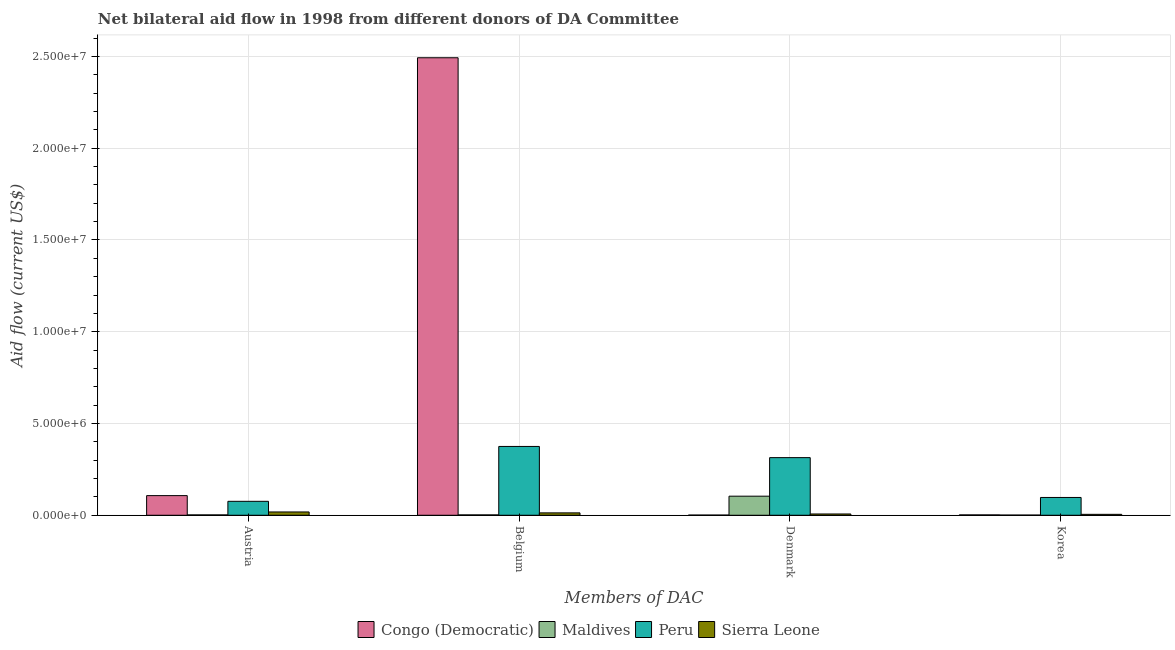Are the number of bars per tick equal to the number of legend labels?
Provide a short and direct response. Yes. Are the number of bars on each tick of the X-axis equal?
Offer a very short reply. Yes. How many bars are there on the 4th tick from the left?
Keep it short and to the point. 4. How many bars are there on the 3rd tick from the right?
Provide a succinct answer. 4. What is the amount of aid given by korea in Sierra Leone?
Your answer should be compact. 5.00e+04. Across all countries, what is the maximum amount of aid given by austria?
Offer a terse response. 1.07e+06. Across all countries, what is the minimum amount of aid given by austria?
Keep it short and to the point. 2.00e+04. In which country was the amount of aid given by austria minimum?
Provide a succinct answer. Maldives. What is the total amount of aid given by belgium in the graph?
Keep it short and to the point. 2.88e+07. What is the difference between the amount of aid given by korea in Sierra Leone and that in Congo (Democratic)?
Your answer should be very brief. 3.00e+04. What is the difference between the amount of aid given by belgium in Congo (Democratic) and the amount of aid given by korea in Maldives?
Keep it short and to the point. 2.49e+07. What is the average amount of aid given by korea per country?
Provide a short and direct response. 2.62e+05. What is the difference between the amount of aid given by austria and amount of aid given by denmark in Sierra Leone?
Offer a terse response. 1.10e+05. In how many countries, is the amount of aid given by belgium greater than 18000000 US$?
Keep it short and to the point. 1. Is the difference between the amount of aid given by korea in Congo (Democratic) and Sierra Leone greater than the difference between the amount of aid given by belgium in Congo (Democratic) and Sierra Leone?
Make the answer very short. No. What is the difference between the highest and the second highest amount of aid given by austria?
Your answer should be compact. 3.10e+05. What is the difference between the highest and the lowest amount of aid given by korea?
Offer a very short reply. 9.60e+05. What does the 2nd bar from the left in Austria represents?
Offer a very short reply. Maldives. What does the 1st bar from the right in Belgium represents?
Keep it short and to the point. Sierra Leone. What is the difference between two consecutive major ticks on the Y-axis?
Provide a succinct answer. 5.00e+06. Are the values on the major ticks of Y-axis written in scientific E-notation?
Ensure brevity in your answer.  Yes. Where does the legend appear in the graph?
Provide a succinct answer. Bottom center. How are the legend labels stacked?
Your answer should be compact. Horizontal. What is the title of the graph?
Your answer should be compact. Net bilateral aid flow in 1998 from different donors of DA Committee. What is the label or title of the X-axis?
Provide a short and direct response. Members of DAC. What is the label or title of the Y-axis?
Your answer should be compact. Aid flow (current US$). What is the Aid flow (current US$) in Congo (Democratic) in Austria?
Provide a succinct answer. 1.07e+06. What is the Aid flow (current US$) in Maldives in Austria?
Give a very brief answer. 2.00e+04. What is the Aid flow (current US$) in Peru in Austria?
Your response must be concise. 7.60e+05. What is the Aid flow (current US$) in Sierra Leone in Austria?
Make the answer very short. 1.80e+05. What is the Aid flow (current US$) of Congo (Democratic) in Belgium?
Offer a terse response. 2.49e+07. What is the Aid flow (current US$) in Maldives in Belgium?
Your response must be concise. 2.00e+04. What is the Aid flow (current US$) in Peru in Belgium?
Provide a succinct answer. 3.75e+06. What is the Aid flow (current US$) of Congo (Democratic) in Denmark?
Your answer should be very brief. 10000. What is the Aid flow (current US$) in Maldives in Denmark?
Your answer should be compact. 1.04e+06. What is the Aid flow (current US$) of Peru in Denmark?
Offer a terse response. 3.14e+06. What is the Aid flow (current US$) in Maldives in Korea?
Make the answer very short. 10000. What is the Aid flow (current US$) of Peru in Korea?
Provide a succinct answer. 9.70e+05. Across all Members of DAC, what is the maximum Aid flow (current US$) of Congo (Democratic)?
Provide a succinct answer. 2.49e+07. Across all Members of DAC, what is the maximum Aid flow (current US$) in Maldives?
Your answer should be very brief. 1.04e+06. Across all Members of DAC, what is the maximum Aid flow (current US$) in Peru?
Offer a very short reply. 3.75e+06. Across all Members of DAC, what is the maximum Aid flow (current US$) of Sierra Leone?
Offer a terse response. 1.80e+05. Across all Members of DAC, what is the minimum Aid flow (current US$) of Maldives?
Your response must be concise. 10000. Across all Members of DAC, what is the minimum Aid flow (current US$) in Peru?
Make the answer very short. 7.60e+05. What is the total Aid flow (current US$) of Congo (Democratic) in the graph?
Your answer should be compact. 2.60e+07. What is the total Aid flow (current US$) in Maldives in the graph?
Your answer should be very brief. 1.09e+06. What is the total Aid flow (current US$) in Peru in the graph?
Ensure brevity in your answer.  8.62e+06. What is the difference between the Aid flow (current US$) of Congo (Democratic) in Austria and that in Belgium?
Keep it short and to the point. -2.39e+07. What is the difference between the Aid flow (current US$) in Maldives in Austria and that in Belgium?
Ensure brevity in your answer.  0. What is the difference between the Aid flow (current US$) in Peru in Austria and that in Belgium?
Ensure brevity in your answer.  -2.99e+06. What is the difference between the Aid flow (current US$) in Congo (Democratic) in Austria and that in Denmark?
Your response must be concise. 1.06e+06. What is the difference between the Aid flow (current US$) of Maldives in Austria and that in Denmark?
Your response must be concise. -1.02e+06. What is the difference between the Aid flow (current US$) in Peru in Austria and that in Denmark?
Provide a succinct answer. -2.38e+06. What is the difference between the Aid flow (current US$) in Sierra Leone in Austria and that in Denmark?
Make the answer very short. 1.10e+05. What is the difference between the Aid flow (current US$) of Congo (Democratic) in Austria and that in Korea?
Ensure brevity in your answer.  1.05e+06. What is the difference between the Aid flow (current US$) in Maldives in Austria and that in Korea?
Give a very brief answer. 10000. What is the difference between the Aid flow (current US$) in Congo (Democratic) in Belgium and that in Denmark?
Offer a terse response. 2.49e+07. What is the difference between the Aid flow (current US$) in Maldives in Belgium and that in Denmark?
Provide a succinct answer. -1.02e+06. What is the difference between the Aid flow (current US$) of Congo (Democratic) in Belgium and that in Korea?
Keep it short and to the point. 2.49e+07. What is the difference between the Aid flow (current US$) in Peru in Belgium and that in Korea?
Offer a terse response. 2.78e+06. What is the difference between the Aid flow (current US$) in Maldives in Denmark and that in Korea?
Your response must be concise. 1.03e+06. What is the difference between the Aid flow (current US$) of Peru in Denmark and that in Korea?
Keep it short and to the point. 2.17e+06. What is the difference between the Aid flow (current US$) in Congo (Democratic) in Austria and the Aid flow (current US$) in Maldives in Belgium?
Make the answer very short. 1.05e+06. What is the difference between the Aid flow (current US$) of Congo (Democratic) in Austria and the Aid flow (current US$) of Peru in Belgium?
Ensure brevity in your answer.  -2.68e+06. What is the difference between the Aid flow (current US$) in Congo (Democratic) in Austria and the Aid flow (current US$) in Sierra Leone in Belgium?
Provide a short and direct response. 9.40e+05. What is the difference between the Aid flow (current US$) of Maldives in Austria and the Aid flow (current US$) of Peru in Belgium?
Provide a succinct answer. -3.73e+06. What is the difference between the Aid flow (current US$) of Peru in Austria and the Aid flow (current US$) of Sierra Leone in Belgium?
Your response must be concise. 6.30e+05. What is the difference between the Aid flow (current US$) of Congo (Democratic) in Austria and the Aid flow (current US$) of Maldives in Denmark?
Make the answer very short. 3.00e+04. What is the difference between the Aid flow (current US$) in Congo (Democratic) in Austria and the Aid flow (current US$) in Peru in Denmark?
Your answer should be very brief. -2.07e+06. What is the difference between the Aid flow (current US$) in Maldives in Austria and the Aid flow (current US$) in Peru in Denmark?
Provide a succinct answer. -3.12e+06. What is the difference between the Aid flow (current US$) in Maldives in Austria and the Aid flow (current US$) in Sierra Leone in Denmark?
Offer a very short reply. -5.00e+04. What is the difference between the Aid flow (current US$) of Peru in Austria and the Aid flow (current US$) of Sierra Leone in Denmark?
Offer a terse response. 6.90e+05. What is the difference between the Aid flow (current US$) of Congo (Democratic) in Austria and the Aid flow (current US$) of Maldives in Korea?
Give a very brief answer. 1.06e+06. What is the difference between the Aid flow (current US$) of Congo (Democratic) in Austria and the Aid flow (current US$) of Sierra Leone in Korea?
Your answer should be compact. 1.02e+06. What is the difference between the Aid flow (current US$) of Maldives in Austria and the Aid flow (current US$) of Peru in Korea?
Offer a very short reply. -9.50e+05. What is the difference between the Aid flow (current US$) in Maldives in Austria and the Aid flow (current US$) in Sierra Leone in Korea?
Make the answer very short. -3.00e+04. What is the difference between the Aid flow (current US$) in Peru in Austria and the Aid flow (current US$) in Sierra Leone in Korea?
Provide a succinct answer. 7.10e+05. What is the difference between the Aid flow (current US$) in Congo (Democratic) in Belgium and the Aid flow (current US$) in Maldives in Denmark?
Make the answer very short. 2.39e+07. What is the difference between the Aid flow (current US$) of Congo (Democratic) in Belgium and the Aid flow (current US$) of Peru in Denmark?
Your answer should be very brief. 2.18e+07. What is the difference between the Aid flow (current US$) in Congo (Democratic) in Belgium and the Aid flow (current US$) in Sierra Leone in Denmark?
Offer a very short reply. 2.49e+07. What is the difference between the Aid flow (current US$) in Maldives in Belgium and the Aid flow (current US$) in Peru in Denmark?
Your answer should be compact. -3.12e+06. What is the difference between the Aid flow (current US$) in Peru in Belgium and the Aid flow (current US$) in Sierra Leone in Denmark?
Offer a terse response. 3.68e+06. What is the difference between the Aid flow (current US$) of Congo (Democratic) in Belgium and the Aid flow (current US$) of Maldives in Korea?
Your answer should be very brief. 2.49e+07. What is the difference between the Aid flow (current US$) in Congo (Democratic) in Belgium and the Aid flow (current US$) in Peru in Korea?
Your answer should be compact. 2.40e+07. What is the difference between the Aid flow (current US$) of Congo (Democratic) in Belgium and the Aid flow (current US$) of Sierra Leone in Korea?
Give a very brief answer. 2.49e+07. What is the difference between the Aid flow (current US$) in Maldives in Belgium and the Aid flow (current US$) in Peru in Korea?
Give a very brief answer. -9.50e+05. What is the difference between the Aid flow (current US$) in Maldives in Belgium and the Aid flow (current US$) in Sierra Leone in Korea?
Offer a very short reply. -3.00e+04. What is the difference between the Aid flow (current US$) of Peru in Belgium and the Aid flow (current US$) of Sierra Leone in Korea?
Provide a short and direct response. 3.70e+06. What is the difference between the Aid flow (current US$) of Congo (Democratic) in Denmark and the Aid flow (current US$) of Maldives in Korea?
Provide a short and direct response. 0. What is the difference between the Aid flow (current US$) in Congo (Democratic) in Denmark and the Aid flow (current US$) in Peru in Korea?
Give a very brief answer. -9.60e+05. What is the difference between the Aid flow (current US$) of Maldives in Denmark and the Aid flow (current US$) of Peru in Korea?
Your answer should be compact. 7.00e+04. What is the difference between the Aid flow (current US$) of Maldives in Denmark and the Aid flow (current US$) of Sierra Leone in Korea?
Provide a succinct answer. 9.90e+05. What is the difference between the Aid flow (current US$) in Peru in Denmark and the Aid flow (current US$) in Sierra Leone in Korea?
Provide a short and direct response. 3.09e+06. What is the average Aid flow (current US$) in Congo (Democratic) per Members of DAC?
Offer a very short reply. 6.51e+06. What is the average Aid flow (current US$) of Maldives per Members of DAC?
Provide a short and direct response. 2.72e+05. What is the average Aid flow (current US$) of Peru per Members of DAC?
Provide a succinct answer. 2.16e+06. What is the average Aid flow (current US$) of Sierra Leone per Members of DAC?
Your answer should be compact. 1.08e+05. What is the difference between the Aid flow (current US$) in Congo (Democratic) and Aid flow (current US$) in Maldives in Austria?
Your response must be concise. 1.05e+06. What is the difference between the Aid flow (current US$) of Congo (Democratic) and Aid flow (current US$) of Sierra Leone in Austria?
Your response must be concise. 8.90e+05. What is the difference between the Aid flow (current US$) of Maldives and Aid flow (current US$) of Peru in Austria?
Offer a terse response. -7.40e+05. What is the difference between the Aid flow (current US$) in Peru and Aid flow (current US$) in Sierra Leone in Austria?
Provide a short and direct response. 5.80e+05. What is the difference between the Aid flow (current US$) of Congo (Democratic) and Aid flow (current US$) of Maldives in Belgium?
Provide a succinct answer. 2.49e+07. What is the difference between the Aid flow (current US$) of Congo (Democratic) and Aid flow (current US$) of Peru in Belgium?
Give a very brief answer. 2.12e+07. What is the difference between the Aid flow (current US$) in Congo (Democratic) and Aid flow (current US$) in Sierra Leone in Belgium?
Your answer should be very brief. 2.48e+07. What is the difference between the Aid flow (current US$) of Maldives and Aid flow (current US$) of Peru in Belgium?
Provide a succinct answer. -3.73e+06. What is the difference between the Aid flow (current US$) in Peru and Aid flow (current US$) in Sierra Leone in Belgium?
Your response must be concise. 3.62e+06. What is the difference between the Aid flow (current US$) in Congo (Democratic) and Aid flow (current US$) in Maldives in Denmark?
Provide a succinct answer. -1.03e+06. What is the difference between the Aid flow (current US$) of Congo (Democratic) and Aid flow (current US$) of Peru in Denmark?
Provide a short and direct response. -3.13e+06. What is the difference between the Aid flow (current US$) in Maldives and Aid flow (current US$) in Peru in Denmark?
Provide a succinct answer. -2.10e+06. What is the difference between the Aid flow (current US$) in Maldives and Aid flow (current US$) in Sierra Leone in Denmark?
Give a very brief answer. 9.70e+05. What is the difference between the Aid flow (current US$) of Peru and Aid flow (current US$) of Sierra Leone in Denmark?
Offer a very short reply. 3.07e+06. What is the difference between the Aid flow (current US$) of Congo (Democratic) and Aid flow (current US$) of Peru in Korea?
Ensure brevity in your answer.  -9.50e+05. What is the difference between the Aid flow (current US$) of Congo (Democratic) and Aid flow (current US$) of Sierra Leone in Korea?
Make the answer very short. -3.00e+04. What is the difference between the Aid flow (current US$) in Maldives and Aid flow (current US$) in Peru in Korea?
Provide a succinct answer. -9.60e+05. What is the difference between the Aid flow (current US$) in Maldives and Aid flow (current US$) in Sierra Leone in Korea?
Keep it short and to the point. -4.00e+04. What is the difference between the Aid flow (current US$) in Peru and Aid flow (current US$) in Sierra Leone in Korea?
Keep it short and to the point. 9.20e+05. What is the ratio of the Aid flow (current US$) of Congo (Democratic) in Austria to that in Belgium?
Provide a succinct answer. 0.04. What is the ratio of the Aid flow (current US$) of Peru in Austria to that in Belgium?
Keep it short and to the point. 0.2. What is the ratio of the Aid flow (current US$) of Sierra Leone in Austria to that in Belgium?
Give a very brief answer. 1.38. What is the ratio of the Aid flow (current US$) of Congo (Democratic) in Austria to that in Denmark?
Keep it short and to the point. 107. What is the ratio of the Aid flow (current US$) of Maldives in Austria to that in Denmark?
Offer a terse response. 0.02. What is the ratio of the Aid flow (current US$) in Peru in Austria to that in Denmark?
Your answer should be very brief. 0.24. What is the ratio of the Aid flow (current US$) of Sierra Leone in Austria to that in Denmark?
Your answer should be compact. 2.57. What is the ratio of the Aid flow (current US$) in Congo (Democratic) in Austria to that in Korea?
Provide a short and direct response. 53.5. What is the ratio of the Aid flow (current US$) in Maldives in Austria to that in Korea?
Offer a very short reply. 2. What is the ratio of the Aid flow (current US$) in Peru in Austria to that in Korea?
Make the answer very short. 0.78. What is the ratio of the Aid flow (current US$) of Sierra Leone in Austria to that in Korea?
Make the answer very short. 3.6. What is the ratio of the Aid flow (current US$) in Congo (Democratic) in Belgium to that in Denmark?
Give a very brief answer. 2493. What is the ratio of the Aid flow (current US$) of Maldives in Belgium to that in Denmark?
Provide a short and direct response. 0.02. What is the ratio of the Aid flow (current US$) of Peru in Belgium to that in Denmark?
Offer a very short reply. 1.19. What is the ratio of the Aid flow (current US$) in Sierra Leone in Belgium to that in Denmark?
Keep it short and to the point. 1.86. What is the ratio of the Aid flow (current US$) of Congo (Democratic) in Belgium to that in Korea?
Your answer should be very brief. 1246.5. What is the ratio of the Aid flow (current US$) in Peru in Belgium to that in Korea?
Provide a short and direct response. 3.87. What is the ratio of the Aid flow (current US$) of Maldives in Denmark to that in Korea?
Your answer should be compact. 104. What is the ratio of the Aid flow (current US$) of Peru in Denmark to that in Korea?
Ensure brevity in your answer.  3.24. What is the ratio of the Aid flow (current US$) of Sierra Leone in Denmark to that in Korea?
Make the answer very short. 1.4. What is the difference between the highest and the second highest Aid flow (current US$) in Congo (Democratic)?
Make the answer very short. 2.39e+07. What is the difference between the highest and the second highest Aid flow (current US$) of Maldives?
Make the answer very short. 1.02e+06. What is the difference between the highest and the lowest Aid flow (current US$) in Congo (Democratic)?
Make the answer very short. 2.49e+07. What is the difference between the highest and the lowest Aid flow (current US$) in Maldives?
Provide a short and direct response. 1.03e+06. What is the difference between the highest and the lowest Aid flow (current US$) in Peru?
Make the answer very short. 2.99e+06. What is the difference between the highest and the lowest Aid flow (current US$) of Sierra Leone?
Provide a short and direct response. 1.30e+05. 